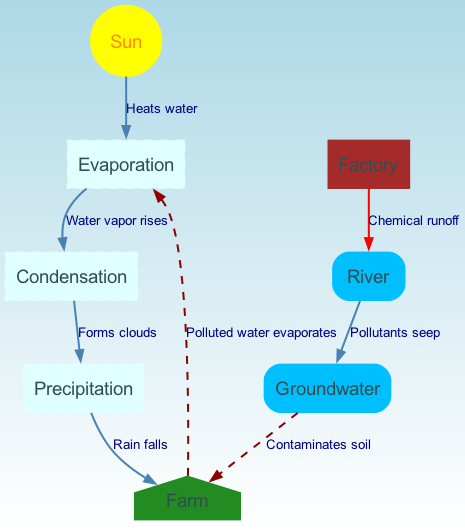What are the key processes in the water cycle represented in the diagram? The key processes shown in the diagram include evaporation, condensation, and precipitation. These processes are linked in a sequential manner, starting with evaporation from water surfaces due to heat from the sun, leading to condensation as water vapor forms clouds, and finally resulting in precipitation, which is indicated as rain falling to the farm.
Answer: Evaporation, condensation, precipitation How does chemical runoff from the factory affect the river? The diagram indicates that chemical runoff from the factory directly flows into the river, as shown by the labeled edge "Chemical runoff." This highlights how pollutants are introduced to the river ecosystem from the factory's operations.
Answer: Chemical runoff What happens to the pollutants in the groundwater? The diagram specifies that pollutants from the river seep into the groundwater, leading to a relationship labeled "Pollutants seep." This means that the pollutants continue to affect the environment by contaminating groundwater resources.
Answer: Contaminates soil How many edges are there that represent negative impacts? Upon examining the diagram, there are three edges that indicate negative impacts: the edge from factory to river (chemical runoff), from river to groundwater (pollutants seep), and from groundwater to farm (contaminates soil). This totals three edges that depict harmful flows.
Answer: 3 What is the final effect of polluted water from the farm? The diagram illustrates that polluted water from the farm evaporates back into the atmosphere, indicated by the label "Polluted water evaporates." This cycle demonstrates how pollutants can re-enter the environment through evaporation, potentially affecting the wider water cycle.
Answer: Polluted water evaporates Which node indicates the source of energy driving evaporation? The source of energy driving evaporation is indicated by the node labeled "Sun." The diagram shows the sun's role in heating water, which initiates the evaporation process.
Answer: Sun How does rain reach the farm? According to the diagram, rain reaches the farm through the process labeled "Rain falls," which follows the precipitation stage in the water cycle that results from condensation of water vapor in clouds.
Answer: Rain falls What shape represents the farm in the diagram? The farm is represented by a node in the shape of a house, which is visually distinct from other shapes in the diagram.
Answer: House 